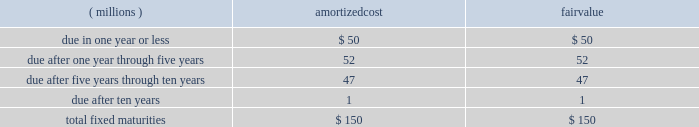Notes to consolidated financial statements the amortized cost and fair value of fixed maturities by contractual maturity as of december 31 , 2007 , are as follows : amortized fair ( millions ) cost value .
Expected maturities may differ from contractual maturities because borrowers may have the right to call or prepay obligations with or without call or prepayment penalties .
For categorization purposes , aon considers any rating of baa or higher by moody 2019s investor services or equivalent rating agency to be investment grade .
Aon 2019s continuing operations have no fixed maturities with an unrealized loss at december 31 , 2007 .
Aon 2019s fixed-maturity portfolio is subject to interest rate , market and credit risks .
With a carrying value of approximately $ 150 million at december 31 , 2007 , aon 2019s total fixed-maturity portfolio is approximately 96% ( 96 % ) investment grade based on market value .
Aon 2019s non publicly-traded fixed maturity portfolio had a carrying value of $ 9 million .
Valuations of these securities primarily reflect the fundamental analysis of the issuer and current market price of comparable securities .
Aon 2019s equity portfolio is comprised of a preferred stock not publicly traded .
This portfolio is subject to interest rate , market , credit , illiquidity , concentration and operational performance risks .
Limited partnership securitization .
In 2001 , aon sold the vast majority of its limited partnership ( lp ) portfolio , valued at $ 450 million , to peps i , a qspe .
The common stock interest in peps i is held by a limited liability company which is owned by aon ( 49% ( 49 % ) ) and by a charitable trust , which is not controlled by aon , established for victims of september 11 ( 51% ( 51 % ) ) .
Approximately $ 171 million of investment grade fixed-maturity securities were sold by peps i to unaffiliated third parties .
Peps i then paid aon 2019s insurance underwriting subsidiaries the $ 171 million in cash and issued to them an additional $ 279 million in fixed-maturity and preferred stock securities .
As part of this transaction , aon is required to purchase from peps i additional fixed-maturity securities in an amount equal to the unfunded limited partnership commitments , as they are requested .
Aon funded $ 2 million of commitments in both 2007 and 2006 .
As of december 31 , 2007 , these unfunded commitments amounted to $ 44 million .
These commitments have specific expiration dates and the general partners may decide not to draw on these commitments .
The carrying value of the peps i preferred stock was $ 168 million and $ 210 million at december 31 , 2007 and 2006 , respectively .
Prior to 2007 , income distributions received from peps i were limited to interest payments on various peps i debt instruments .
Beginning in 2007 , peps i had redeemed or collateralized all of its debt , and as a result , began to pay preferred income distributions .
In 2007 , the company received $ 61 million of income distributions from peps i , which are included in investment income .
Aon corporation .
What portion of the the total fixed maturities is due in one year or less? 
Computations: (50 / 150)
Answer: 0.33333. 